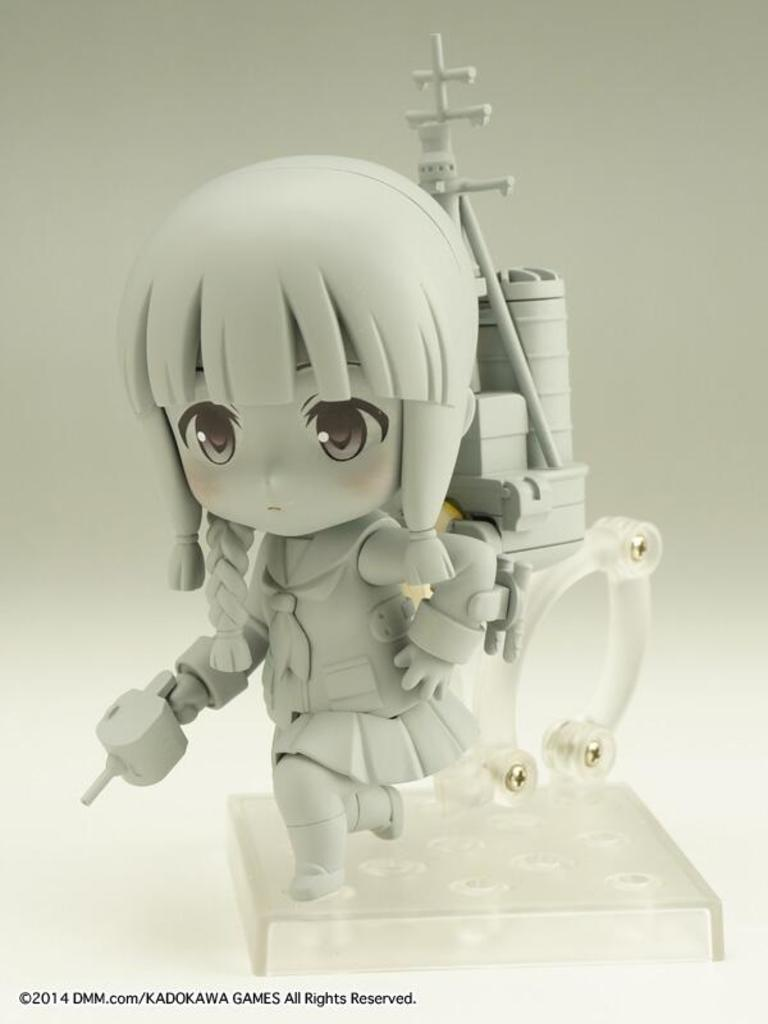What is the main subject in the middle of the image? There is a toy in the middle of the image. What color is the background of the image? The background of the image appears to be white. How does the toy control the shop in the image? There is no shop present in the image, and the toy does not have the ability to control anything. 